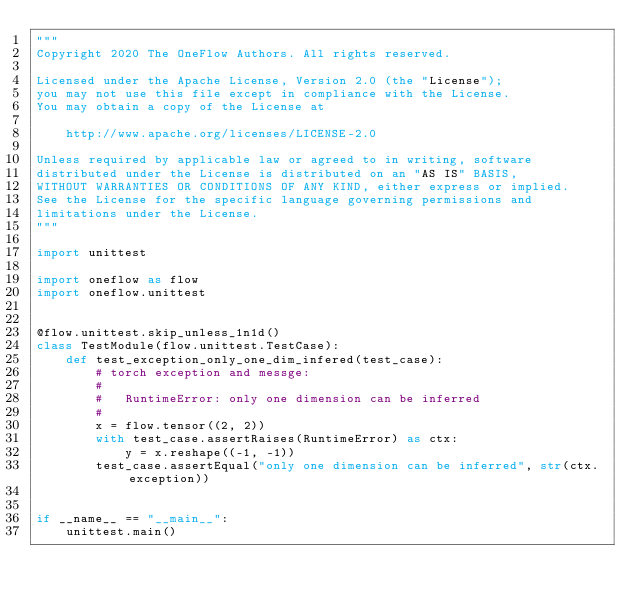Convert code to text. <code><loc_0><loc_0><loc_500><loc_500><_Python_>"""
Copyright 2020 The OneFlow Authors. All rights reserved.

Licensed under the Apache License, Version 2.0 (the "License");
you may not use this file except in compliance with the License.
You may obtain a copy of the License at

    http://www.apache.org/licenses/LICENSE-2.0

Unless required by applicable law or agreed to in writing, software
distributed under the License is distributed on an "AS IS" BASIS,
WITHOUT WARRANTIES OR CONDITIONS OF ANY KIND, either express or implied.
See the License for the specific language governing permissions and
limitations under the License.
"""

import unittest

import oneflow as flow
import oneflow.unittest


@flow.unittest.skip_unless_1n1d()
class TestModule(flow.unittest.TestCase):
    def test_exception_only_one_dim_infered(test_case):
        # torch exception and messge:
        #
        #   RuntimeError: only one dimension can be inferred
        #
        x = flow.tensor((2, 2))
        with test_case.assertRaises(RuntimeError) as ctx:
            y = x.reshape((-1, -1))
        test_case.assertEqual("only one dimension can be inferred", str(ctx.exception))


if __name__ == "__main__":
    unittest.main()
</code> 